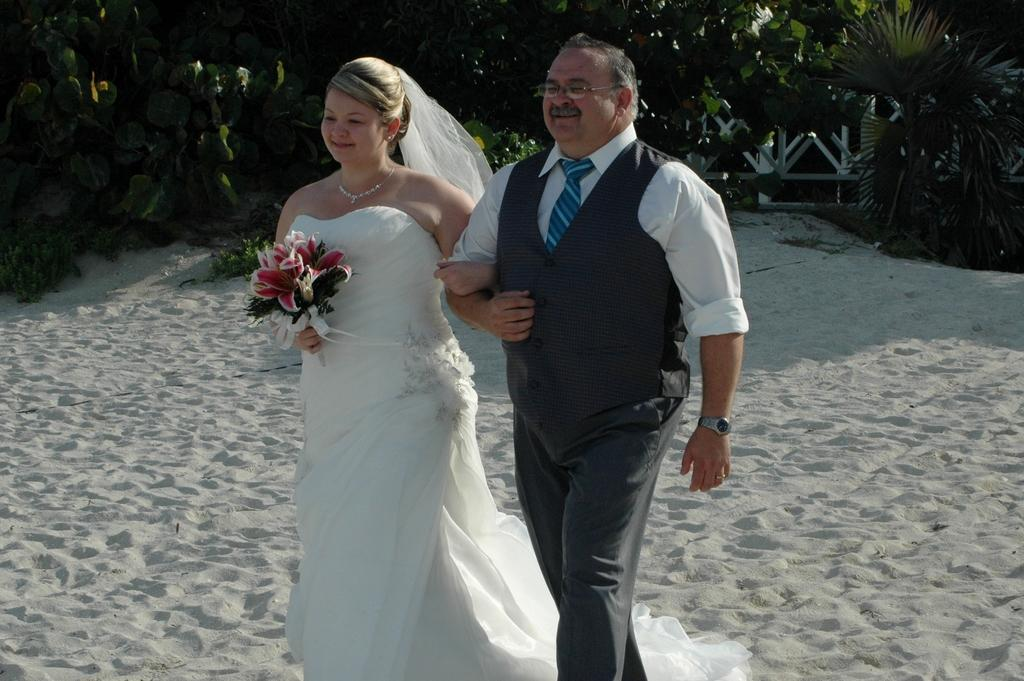What is the main subject of the image? The image contains a couple. What is the person on the left wearing? The person on the left is wearing a white gown and veil. What is the person on the left holding? The person on the left is holding a flower bouquet. What can be seen in the background of the image? There are trees visible in the background of the image. What type of cake is being served at the school in the image? There is no school or cake present in the image; it features a couple with the person on the left wearing a white gown, veil, and holding a flower bouquet, with trees visible in the background. 